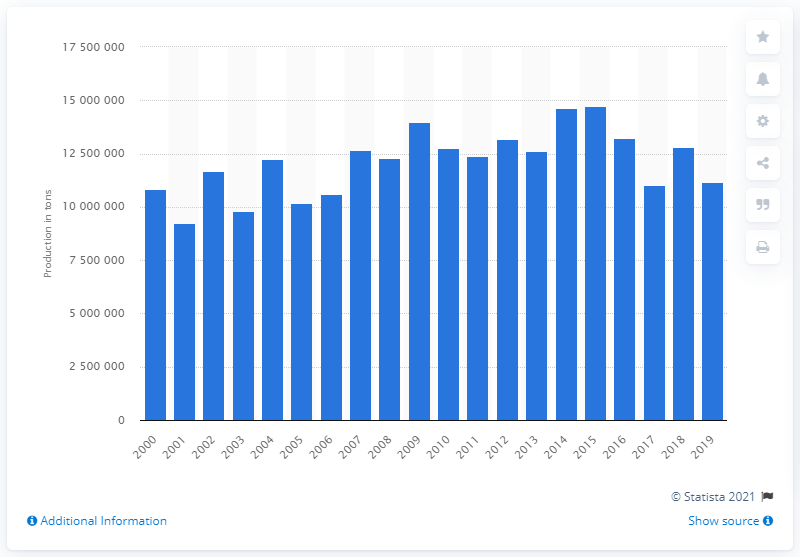Mention a couple of crucial points in this snapshot. In the United States, the production of tomatoes for processing from 2000 to 2019 was 111,862,560 metric tons. 